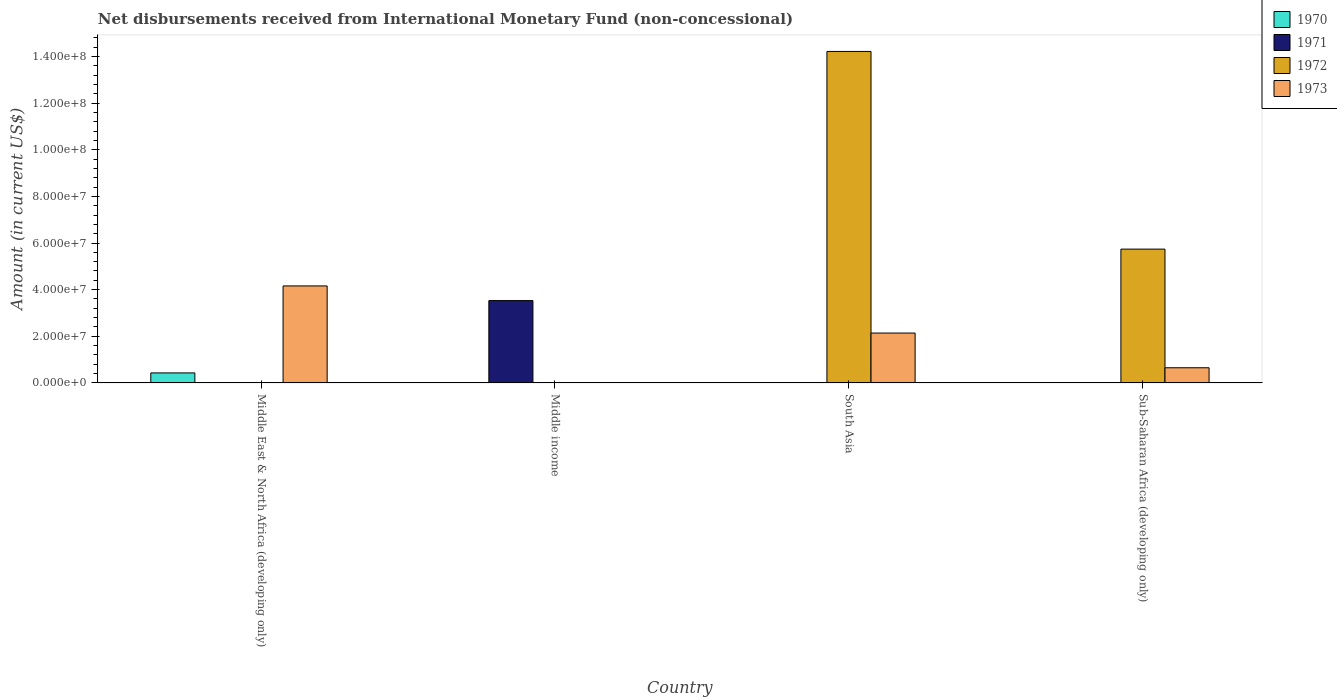How many different coloured bars are there?
Provide a succinct answer. 4. How many bars are there on the 2nd tick from the right?
Offer a terse response. 2. What is the label of the 3rd group of bars from the left?
Offer a terse response. South Asia. In how many cases, is the number of bars for a given country not equal to the number of legend labels?
Provide a succinct answer. 4. What is the amount of disbursements received from International Monetary Fund in 1972 in South Asia?
Give a very brief answer. 1.42e+08. Across all countries, what is the maximum amount of disbursements received from International Monetary Fund in 1973?
Make the answer very short. 4.16e+07. Across all countries, what is the minimum amount of disbursements received from International Monetary Fund in 1970?
Make the answer very short. 0. In which country was the amount of disbursements received from International Monetary Fund in 1973 maximum?
Your response must be concise. Middle East & North Africa (developing only). What is the total amount of disbursements received from International Monetary Fund in 1970 in the graph?
Offer a very short reply. 4.30e+06. What is the difference between the amount of disbursements received from International Monetary Fund in 1973 in South Asia and that in Sub-Saharan Africa (developing only)?
Ensure brevity in your answer.  1.49e+07. What is the difference between the amount of disbursements received from International Monetary Fund in 1970 in South Asia and the amount of disbursements received from International Monetary Fund in 1972 in Sub-Saharan Africa (developing only)?
Your answer should be compact. -5.74e+07. What is the average amount of disbursements received from International Monetary Fund in 1970 per country?
Offer a very short reply. 1.08e+06. What is the difference between the amount of disbursements received from International Monetary Fund of/in 1973 and amount of disbursements received from International Monetary Fund of/in 1970 in Middle East & North Africa (developing only)?
Provide a succinct answer. 3.73e+07. What is the ratio of the amount of disbursements received from International Monetary Fund in 1972 in South Asia to that in Sub-Saharan Africa (developing only)?
Ensure brevity in your answer.  2.48. What is the difference between the highest and the second highest amount of disbursements received from International Monetary Fund in 1973?
Your answer should be very brief. 3.51e+07. What is the difference between the highest and the lowest amount of disbursements received from International Monetary Fund in 1972?
Make the answer very short. 1.42e+08. How many bars are there?
Your response must be concise. 7. Are all the bars in the graph horizontal?
Your response must be concise. No. How many countries are there in the graph?
Your response must be concise. 4. What is the difference between two consecutive major ticks on the Y-axis?
Give a very brief answer. 2.00e+07. Are the values on the major ticks of Y-axis written in scientific E-notation?
Your response must be concise. Yes. Does the graph contain any zero values?
Offer a very short reply. Yes. What is the title of the graph?
Ensure brevity in your answer.  Net disbursements received from International Monetary Fund (non-concessional). What is the label or title of the Y-axis?
Your answer should be very brief. Amount (in current US$). What is the Amount (in current US$) of 1970 in Middle East & North Africa (developing only)?
Make the answer very short. 4.30e+06. What is the Amount (in current US$) in 1973 in Middle East & North Africa (developing only)?
Your response must be concise. 4.16e+07. What is the Amount (in current US$) of 1971 in Middle income?
Keep it short and to the point. 3.53e+07. What is the Amount (in current US$) of 1973 in Middle income?
Your answer should be compact. 0. What is the Amount (in current US$) in 1972 in South Asia?
Provide a succinct answer. 1.42e+08. What is the Amount (in current US$) in 1973 in South Asia?
Offer a very short reply. 2.14e+07. What is the Amount (in current US$) of 1971 in Sub-Saharan Africa (developing only)?
Your response must be concise. 0. What is the Amount (in current US$) of 1972 in Sub-Saharan Africa (developing only)?
Your response must be concise. 5.74e+07. What is the Amount (in current US$) of 1973 in Sub-Saharan Africa (developing only)?
Keep it short and to the point. 6.51e+06. Across all countries, what is the maximum Amount (in current US$) in 1970?
Your answer should be compact. 4.30e+06. Across all countries, what is the maximum Amount (in current US$) of 1971?
Make the answer very short. 3.53e+07. Across all countries, what is the maximum Amount (in current US$) of 1972?
Offer a very short reply. 1.42e+08. Across all countries, what is the maximum Amount (in current US$) of 1973?
Your answer should be compact. 4.16e+07. Across all countries, what is the minimum Amount (in current US$) in 1970?
Offer a very short reply. 0. What is the total Amount (in current US$) in 1970 in the graph?
Provide a succinct answer. 4.30e+06. What is the total Amount (in current US$) of 1971 in the graph?
Offer a terse response. 3.53e+07. What is the total Amount (in current US$) of 1972 in the graph?
Ensure brevity in your answer.  2.00e+08. What is the total Amount (in current US$) in 1973 in the graph?
Give a very brief answer. 6.95e+07. What is the difference between the Amount (in current US$) of 1973 in Middle East & North Africa (developing only) and that in South Asia?
Provide a short and direct response. 2.02e+07. What is the difference between the Amount (in current US$) in 1973 in Middle East & North Africa (developing only) and that in Sub-Saharan Africa (developing only)?
Provide a succinct answer. 3.51e+07. What is the difference between the Amount (in current US$) in 1972 in South Asia and that in Sub-Saharan Africa (developing only)?
Offer a terse response. 8.48e+07. What is the difference between the Amount (in current US$) of 1973 in South Asia and that in Sub-Saharan Africa (developing only)?
Provide a short and direct response. 1.49e+07. What is the difference between the Amount (in current US$) in 1970 in Middle East & North Africa (developing only) and the Amount (in current US$) in 1971 in Middle income?
Your response must be concise. -3.10e+07. What is the difference between the Amount (in current US$) of 1970 in Middle East & North Africa (developing only) and the Amount (in current US$) of 1972 in South Asia?
Keep it short and to the point. -1.38e+08. What is the difference between the Amount (in current US$) of 1970 in Middle East & North Africa (developing only) and the Amount (in current US$) of 1973 in South Asia?
Keep it short and to the point. -1.71e+07. What is the difference between the Amount (in current US$) of 1970 in Middle East & North Africa (developing only) and the Amount (in current US$) of 1972 in Sub-Saharan Africa (developing only)?
Offer a very short reply. -5.31e+07. What is the difference between the Amount (in current US$) in 1970 in Middle East & North Africa (developing only) and the Amount (in current US$) in 1973 in Sub-Saharan Africa (developing only)?
Keep it short and to the point. -2.21e+06. What is the difference between the Amount (in current US$) in 1971 in Middle income and the Amount (in current US$) in 1972 in South Asia?
Offer a terse response. -1.07e+08. What is the difference between the Amount (in current US$) of 1971 in Middle income and the Amount (in current US$) of 1973 in South Asia?
Keep it short and to the point. 1.39e+07. What is the difference between the Amount (in current US$) in 1971 in Middle income and the Amount (in current US$) in 1972 in Sub-Saharan Africa (developing only)?
Ensure brevity in your answer.  -2.21e+07. What is the difference between the Amount (in current US$) of 1971 in Middle income and the Amount (in current US$) of 1973 in Sub-Saharan Africa (developing only)?
Offer a very short reply. 2.88e+07. What is the difference between the Amount (in current US$) of 1972 in South Asia and the Amount (in current US$) of 1973 in Sub-Saharan Africa (developing only)?
Provide a short and direct response. 1.36e+08. What is the average Amount (in current US$) in 1970 per country?
Your answer should be very brief. 1.08e+06. What is the average Amount (in current US$) in 1971 per country?
Your response must be concise. 8.83e+06. What is the average Amount (in current US$) in 1972 per country?
Offer a terse response. 4.99e+07. What is the average Amount (in current US$) in 1973 per country?
Your answer should be compact. 1.74e+07. What is the difference between the Amount (in current US$) in 1970 and Amount (in current US$) in 1973 in Middle East & North Africa (developing only)?
Make the answer very short. -3.73e+07. What is the difference between the Amount (in current US$) in 1972 and Amount (in current US$) in 1973 in South Asia?
Your answer should be very brief. 1.21e+08. What is the difference between the Amount (in current US$) in 1972 and Amount (in current US$) in 1973 in Sub-Saharan Africa (developing only)?
Ensure brevity in your answer.  5.09e+07. What is the ratio of the Amount (in current US$) in 1973 in Middle East & North Africa (developing only) to that in South Asia?
Your answer should be very brief. 1.94. What is the ratio of the Amount (in current US$) in 1973 in Middle East & North Africa (developing only) to that in Sub-Saharan Africa (developing only)?
Provide a succinct answer. 6.39. What is the ratio of the Amount (in current US$) of 1972 in South Asia to that in Sub-Saharan Africa (developing only)?
Offer a terse response. 2.48. What is the ratio of the Amount (in current US$) in 1973 in South Asia to that in Sub-Saharan Africa (developing only)?
Your answer should be very brief. 3.29. What is the difference between the highest and the second highest Amount (in current US$) of 1973?
Make the answer very short. 2.02e+07. What is the difference between the highest and the lowest Amount (in current US$) in 1970?
Provide a succinct answer. 4.30e+06. What is the difference between the highest and the lowest Amount (in current US$) of 1971?
Your answer should be very brief. 3.53e+07. What is the difference between the highest and the lowest Amount (in current US$) in 1972?
Provide a succinct answer. 1.42e+08. What is the difference between the highest and the lowest Amount (in current US$) in 1973?
Keep it short and to the point. 4.16e+07. 